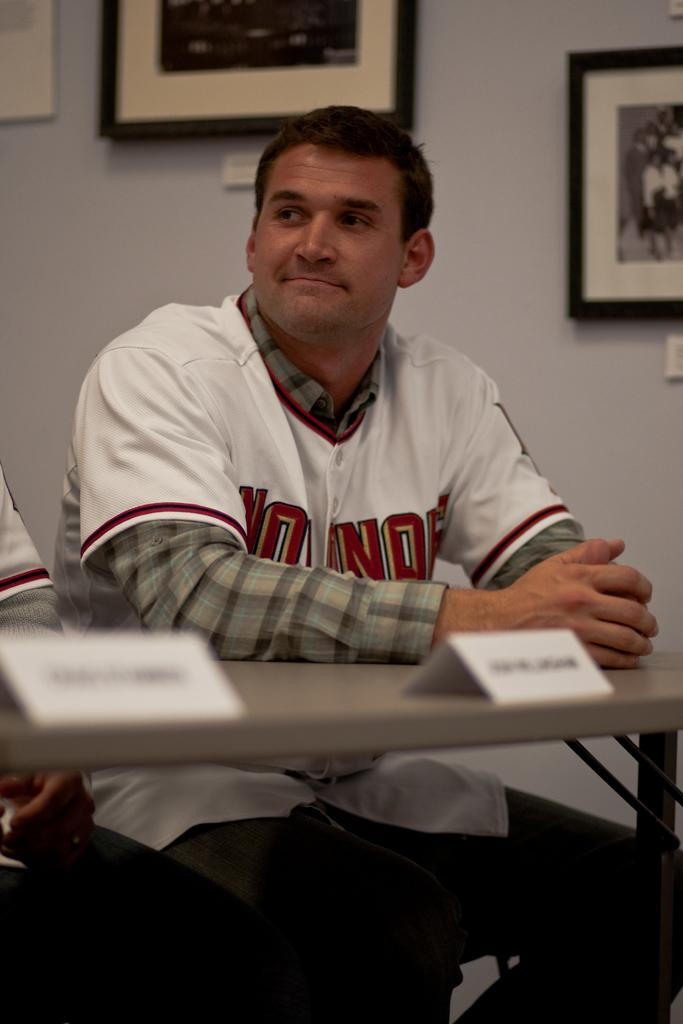What is the main subject of the image? There is a man in the image. What is the man wearing? The man is wearing a white t-shirt. What is the man doing in the image? The man is sitting. What is in front of the man? There is a table in front of the man. What is on the table? There are name boards on the table. What can be seen in the background of the image? There is a wall in the background of the image. What is on the wall? There is a photo frame on the wall. Where is the bomb located in the image? There is no bomb present in the image. What position is the man in the image? The man is sitting in the image. 